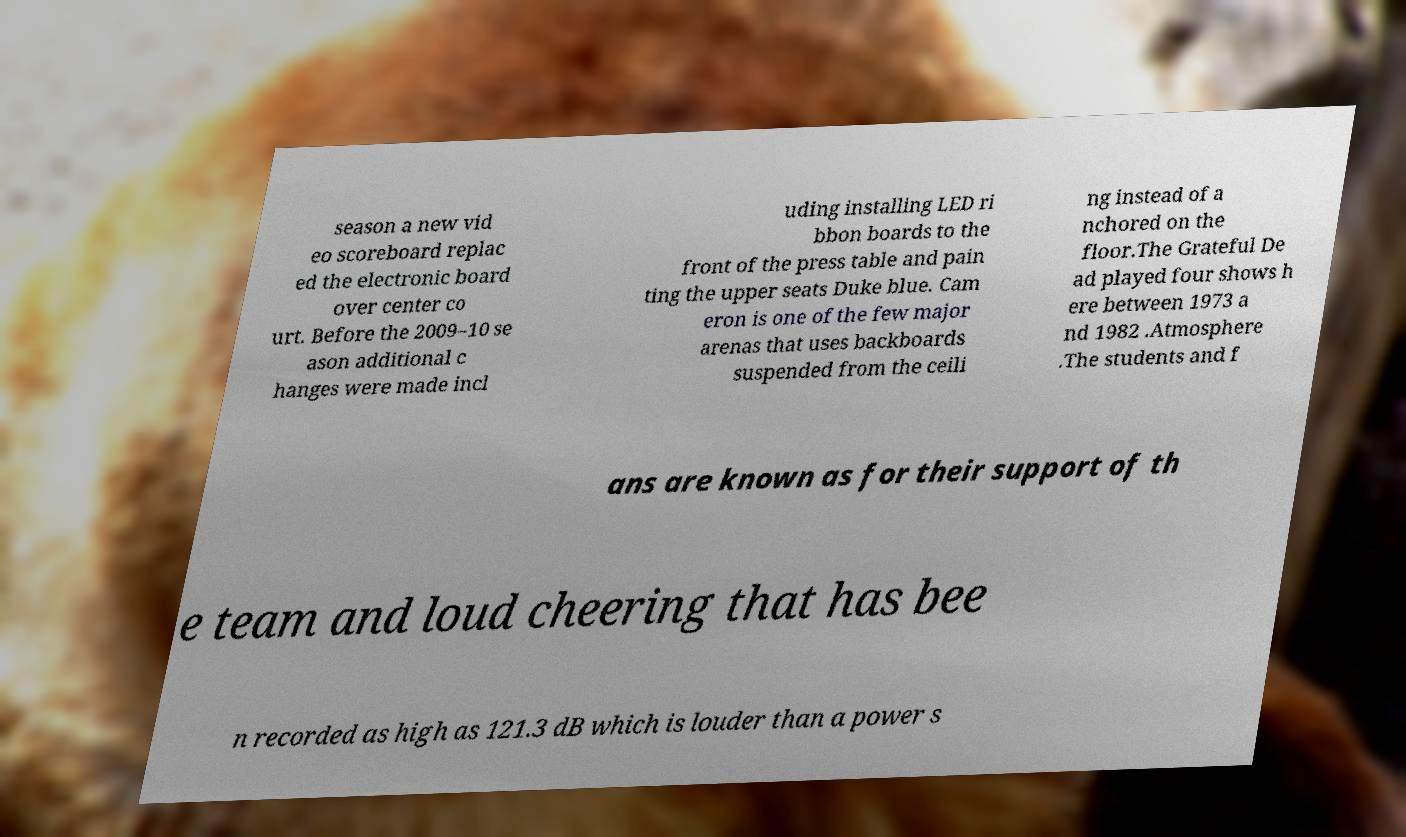Please read and relay the text visible in this image. What does it say? season a new vid eo scoreboard replac ed the electronic board over center co urt. Before the 2009–10 se ason additional c hanges were made incl uding installing LED ri bbon boards to the front of the press table and pain ting the upper seats Duke blue. Cam eron is one of the few major arenas that uses backboards suspended from the ceili ng instead of a nchored on the floor.The Grateful De ad played four shows h ere between 1973 a nd 1982 .Atmosphere .The students and f ans are known as for their support of th e team and loud cheering that has bee n recorded as high as 121.3 dB which is louder than a power s 